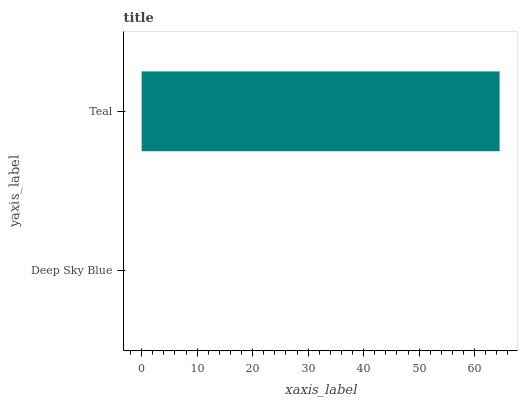Is Deep Sky Blue the minimum?
Answer yes or no. Yes. Is Teal the maximum?
Answer yes or no. Yes. Is Teal the minimum?
Answer yes or no. No. Is Teal greater than Deep Sky Blue?
Answer yes or no. Yes. Is Deep Sky Blue less than Teal?
Answer yes or no. Yes. Is Deep Sky Blue greater than Teal?
Answer yes or no. No. Is Teal less than Deep Sky Blue?
Answer yes or no. No. Is Teal the high median?
Answer yes or no. Yes. Is Deep Sky Blue the low median?
Answer yes or no. Yes. Is Deep Sky Blue the high median?
Answer yes or no. No. Is Teal the low median?
Answer yes or no. No. 